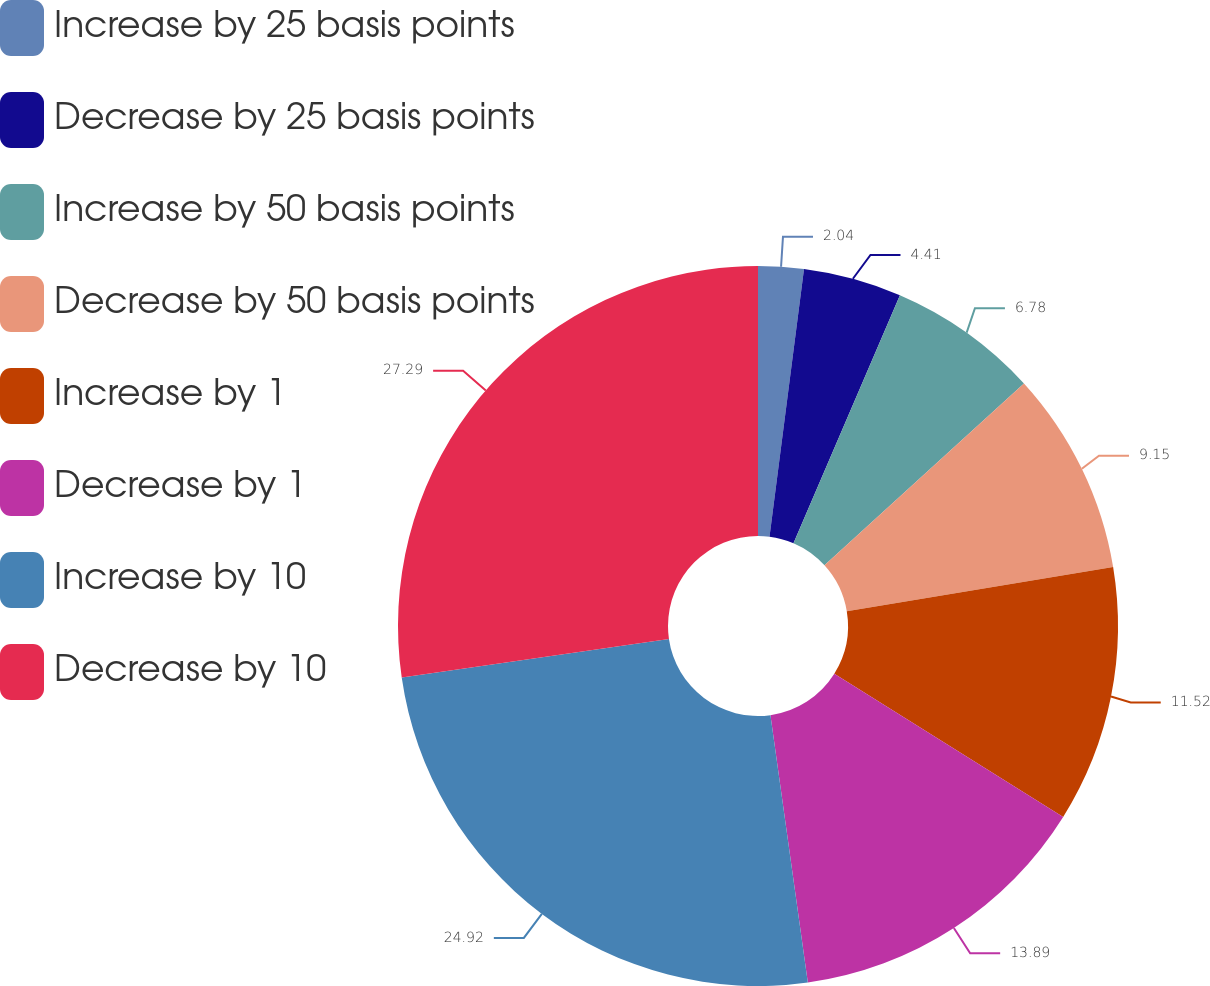<chart> <loc_0><loc_0><loc_500><loc_500><pie_chart><fcel>Increase by 25 basis points<fcel>Decrease by 25 basis points<fcel>Increase by 50 basis points<fcel>Decrease by 50 basis points<fcel>Increase by 1<fcel>Decrease by 1<fcel>Increase by 10<fcel>Decrease by 10<nl><fcel>2.04%<fcel>4.41%<fcel>6.78%<fcel>9.15%<fcel>11.52%<fcel>13.89%<fcel>24.92%<fcel>27.29%<nl></chart> 